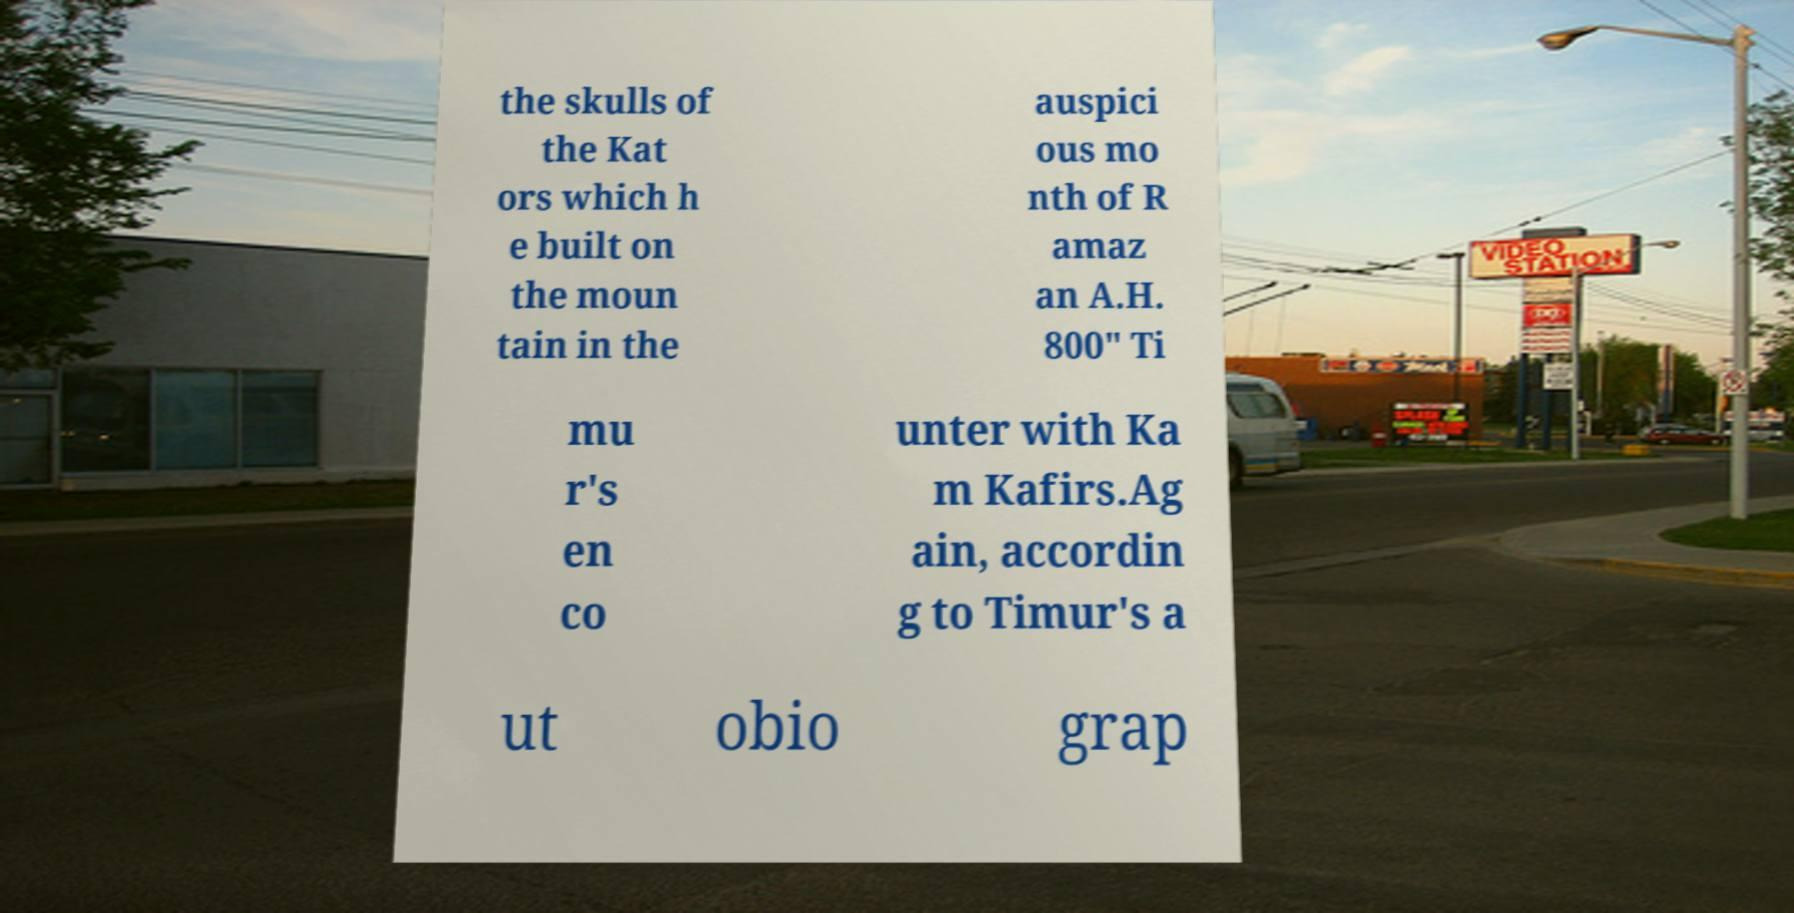Please read and relay the text visible in this image. What does it say? the skulls of the Kat ors which h e built on the moun tain in the auspici ous mo nth of R amaz an A.H. 800" Ti mu r's en co unter with Ka m Kafirs.Ag ain, accordin g to Timur's a ut obio grap 